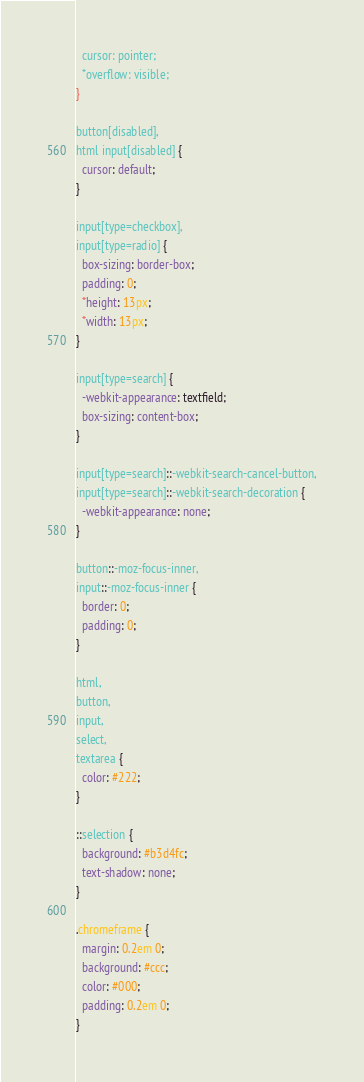<code> <loc_0><loc_0><loc_500><loc_500><_CSS_>  cursor: pointer;
  *overflow: visible;
}

button[disabled],
html input[disabled] {
  cursor: default;
}

input[type=checkbox],
input[type=radio] {
  box-sizing: border-box;
  padding: 0;
  *height: 13px;
  *width: 13px;
}

input[type=search] {
  -webkit-appearance: textfield;
  box-sizing: content-box;
}

input[type=search]::-webkit-search-cancel-button,
input[type=search]::-webkit-search-decoration {
  -webkit-appearance: none;
}

button::-moz-focus-inner,
input::-moz-focus-inner {
  border: 0;
  padding: 0;
}

html,
button,
input,
select,
textarea {
  color: #222;
}

::selection {
  background: #b3d4fc;
  text-shadow: none;
}

.chromeframe {
  margin: 0.2em 0;
  background: #ccc;
  color: #000;
  padding: 0.2em 0;
}</code> 